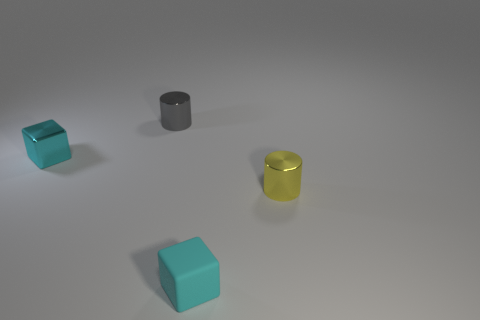Add 1 small yellow cylinders. How many objects exist? 5 Add 4 cylinders. How many cylinders exist? 6 Subtract 0 red cylinders. How many objects are left? 4 Subtract all tiny yellow metal cylinders. Subtract all cylinders. How many objects are left? 1 Add 1 blocks. How many blocks are left? 3 